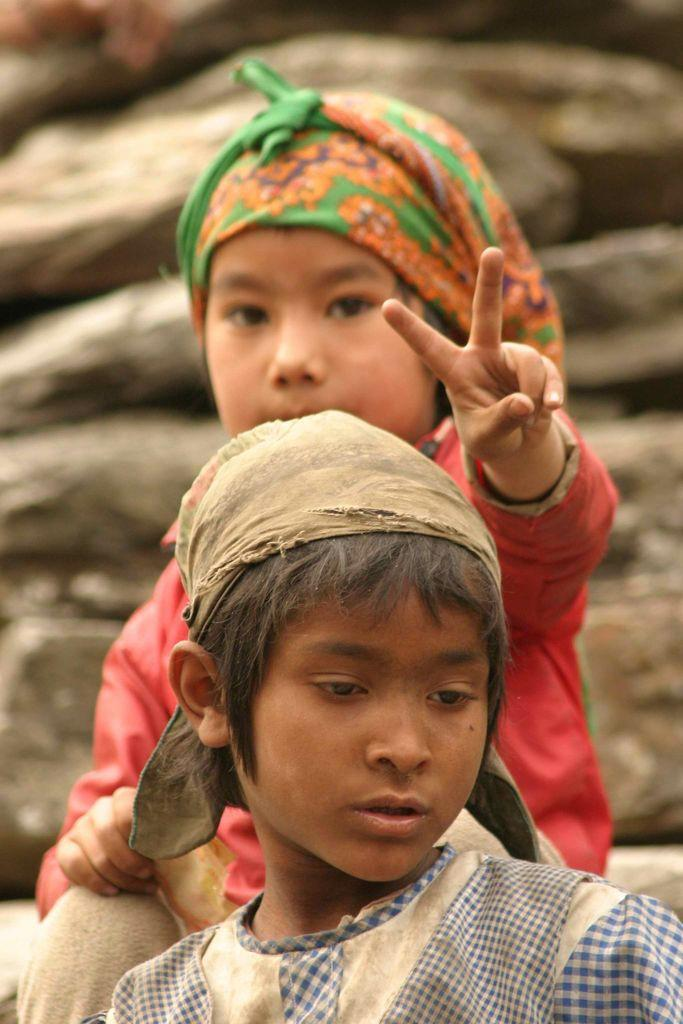How many boys are present in the image? There are two boys visible in the foreground of the image. Can you describe the boys' location in the image? The boys are in the foreground of the image. What might be visible in the background of the image? There may be some stones visible in the background of the image. What game are the boys playing in the image? There is no indication of a game being played in the image. 